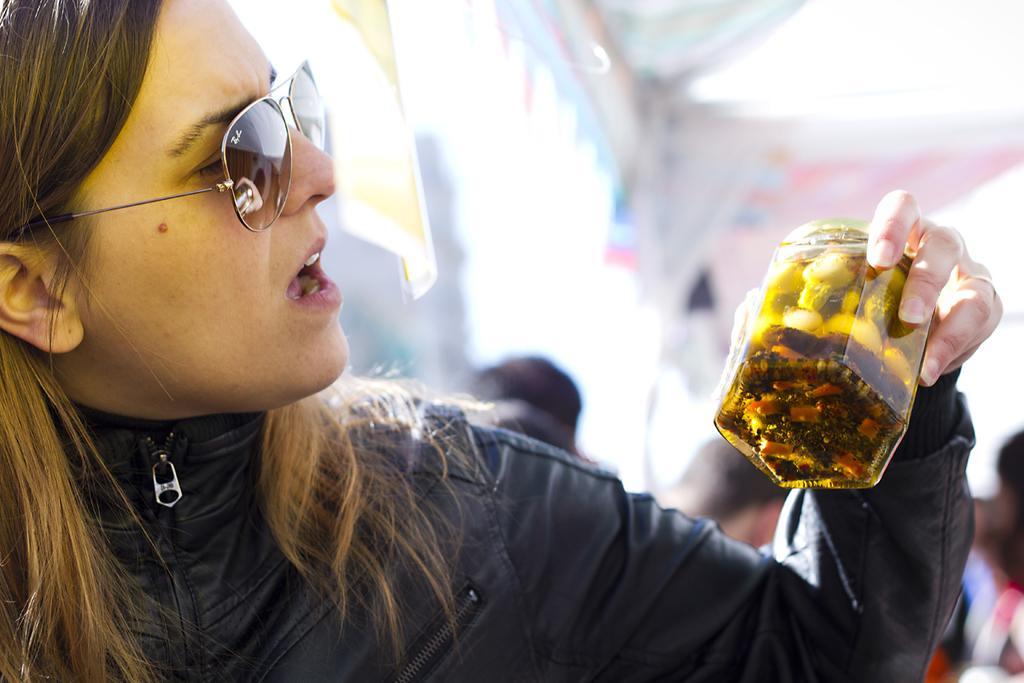Can you describe this image briefly? In the center of the image we can see a woman holding a jar. 